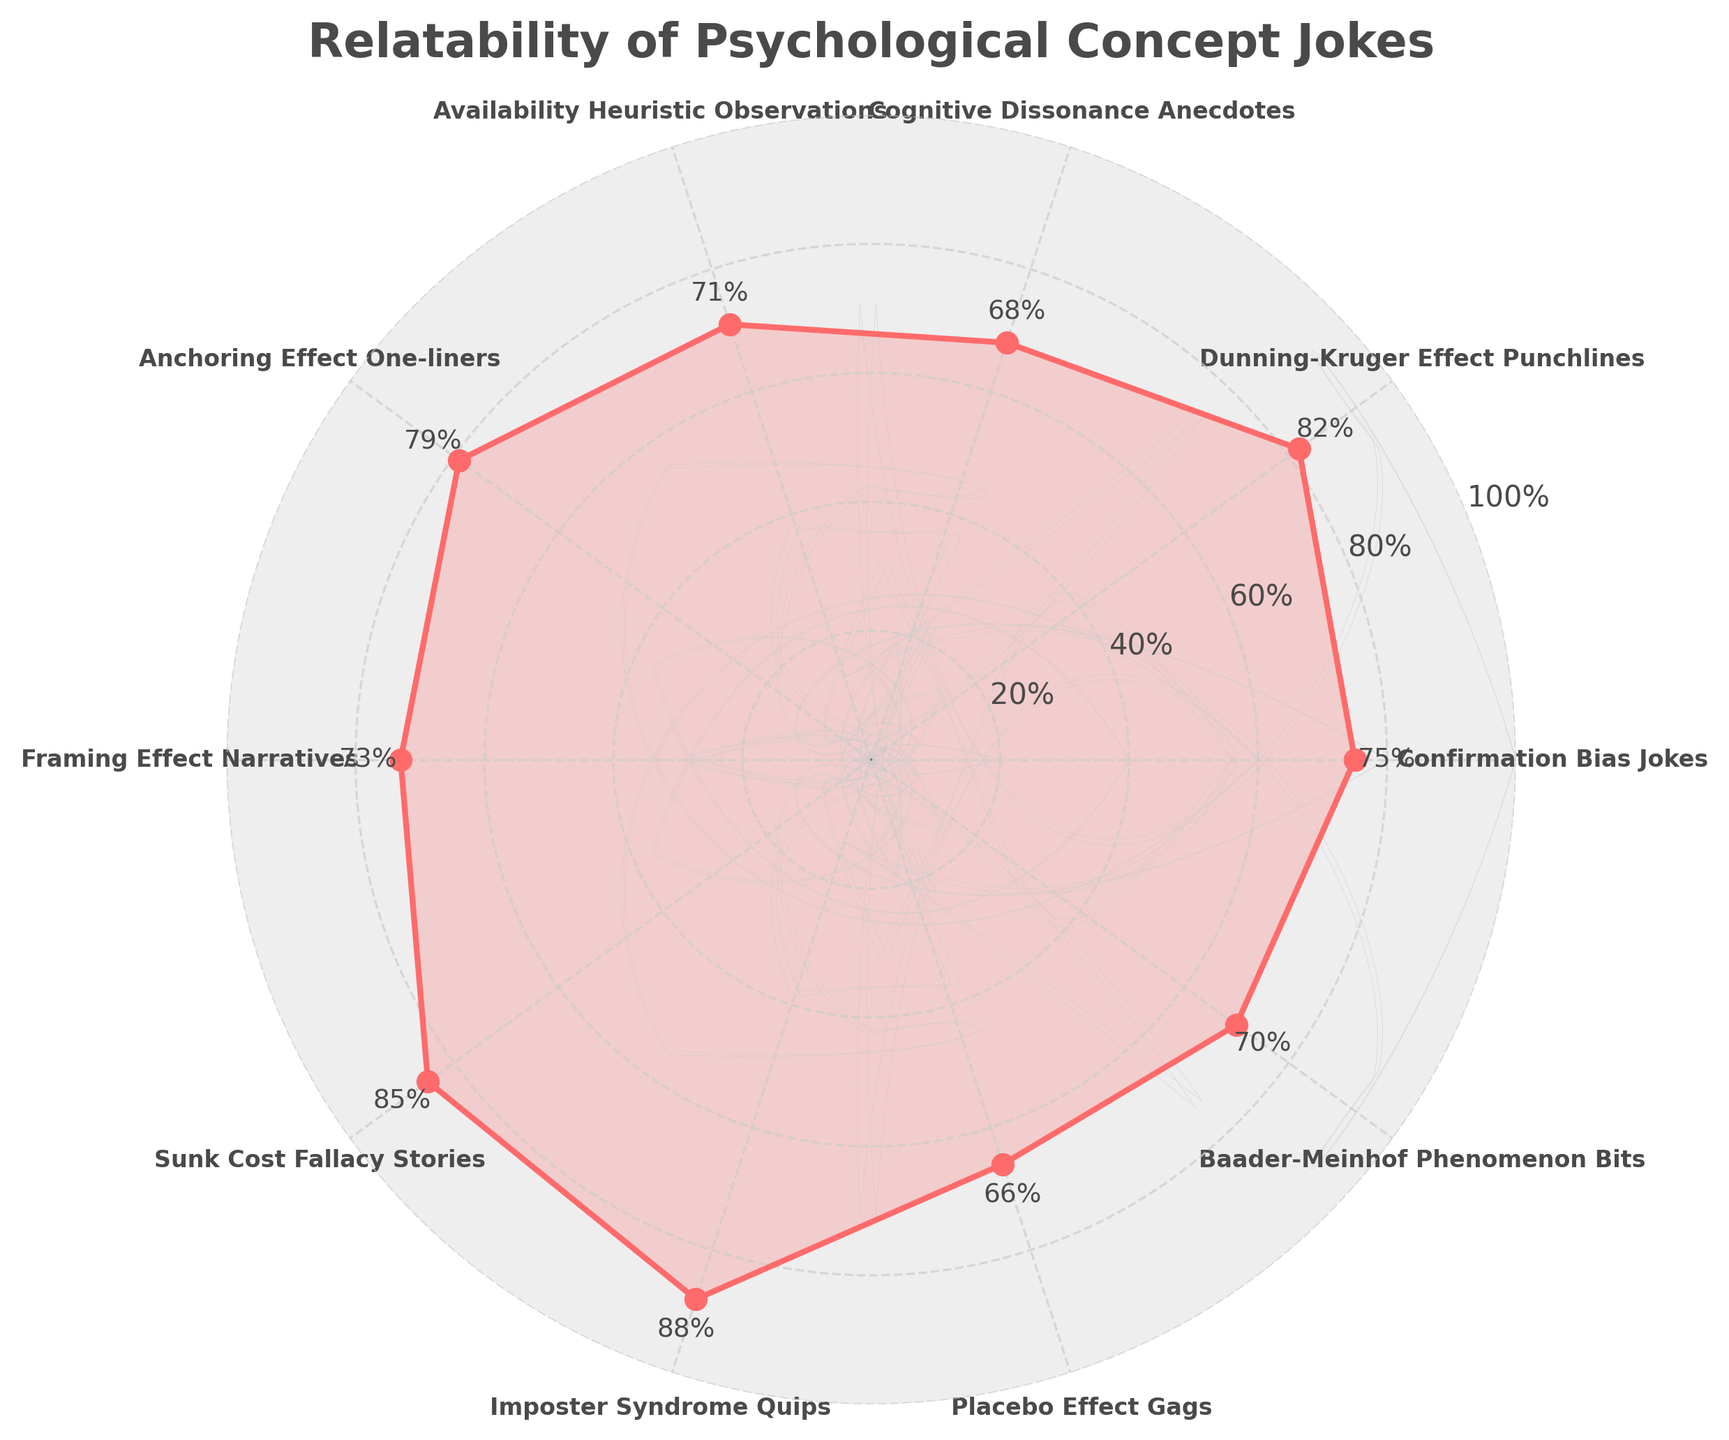What is the title of the chart? The title of the chart is located at the top and is clearly visible in large, bold font. It states "Relatability of Psychological Concept Jokes".
Answer: Relatability of Psychological Concept Jokes How many joke categories are included in the chart? To find the number of joke categories, count the distinct segments or labels around the chart. Each label represents a different joke category.
Answer: 10 Which joke category has the highest relatability score? By looking at the scores next to the labels around the chart, identify the category with the highest score. Imposter Syndrome Quips has the highest score at 88%.
Answer: Imposter Syndrome Quips What are the relatability scores of Cognitive Dissonance Anecdotes and Placebo Effect Gags? Locate the labels "Cognitive Dissonance Anecdotes" and "Placebo Effect Gags" around the chart and read the scores next to them, which are 68% and 66%, respectively.
Answer: 68% and 66% What is the average relatability score of all joke categories? Sum the relatability scores of all joke categories (75 + 82 + 68 + 71 + 79 + 73 + 85 + 88 + 66 + 70) = 757 and divide by the number of categories (10). The average score is 757/10 = 75.7%.
Answer: 75.7% Which joke category has a relatability score closest to 70%? Identify the score closest to 70% by comparing the scores. Both "Availability Heuristic Observations" and "Baader-Meinhof Phenomenon Bits" have scores close to 70% (71% and 70%, respectively).
Answer: Baader-Meinhof Phenomenon Bits What is the difference in relatability score between Anchoring Effect One-liners and Sunk Cost Fallacy Stories? Find the scores for both categories (79% for Anchoring Effect One-liners and 85% for Sunk Cost Fallacy Stories) and compute the difference, which is 85 - 79 = 6%.
Answer: 6% Which joke category has the second-highest relatability score? The highest score is 88% for Imposter Syndrome Quips. The next highest score is 85% for Sunk Cost Fallacy Stories.
Answer: Sunk Cost Fallacy Stories How does the relatability score of Confirmation Bias Jokes compare to that of Framing Effect Narratives? Compare the scores for Confirmation Bias Jokes (75%) and Framing Effect Narratives (73%). Confirmation Bias Jokes have a higher score.
Answer: Higher What are the categories with scores above 80%? Identify and list the categories with scores above 80%, which are "Dunning-Kruger Effect Punchlines" (82%), "Sunk Cost Fallacy Stories" (85%), and "Imposter Syndrome Quips" (88%).
Answer: Dunning-Kruger Effect Punchlines, Sunk Cost Fallacy Stories, Imposter Syndrome Quips 